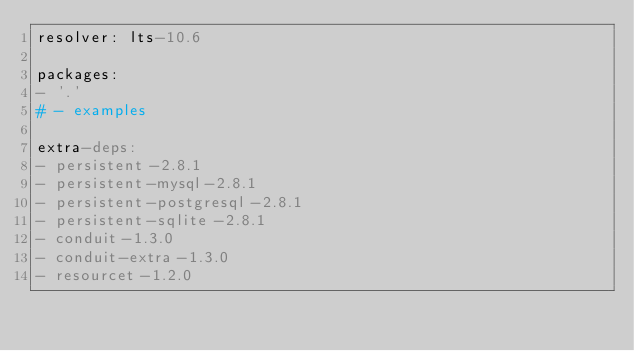<code> <loc_0><loc_0><loc_500><loc_500><_YAML_>resolver: lts-10.6

packages:
- '.'
# - examples

extra-deps:
- persistent-2.8.1
- persistent-mysql-2.8.1
- persistent-postgresql-2.8.1
- persistent-sqlite-2.8.1
- conduit-1.3.0
- conduit-extra-1.3.0
- resourcet-1.2.0
</code> 